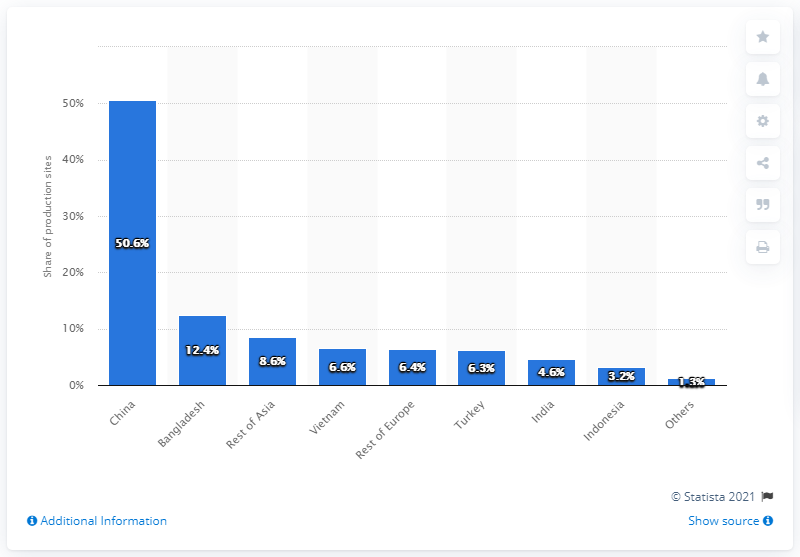Indicate a few pertinent items in this graphic. In 2014, approximately 50.6% of ESPRIT's production sites were located in China. 